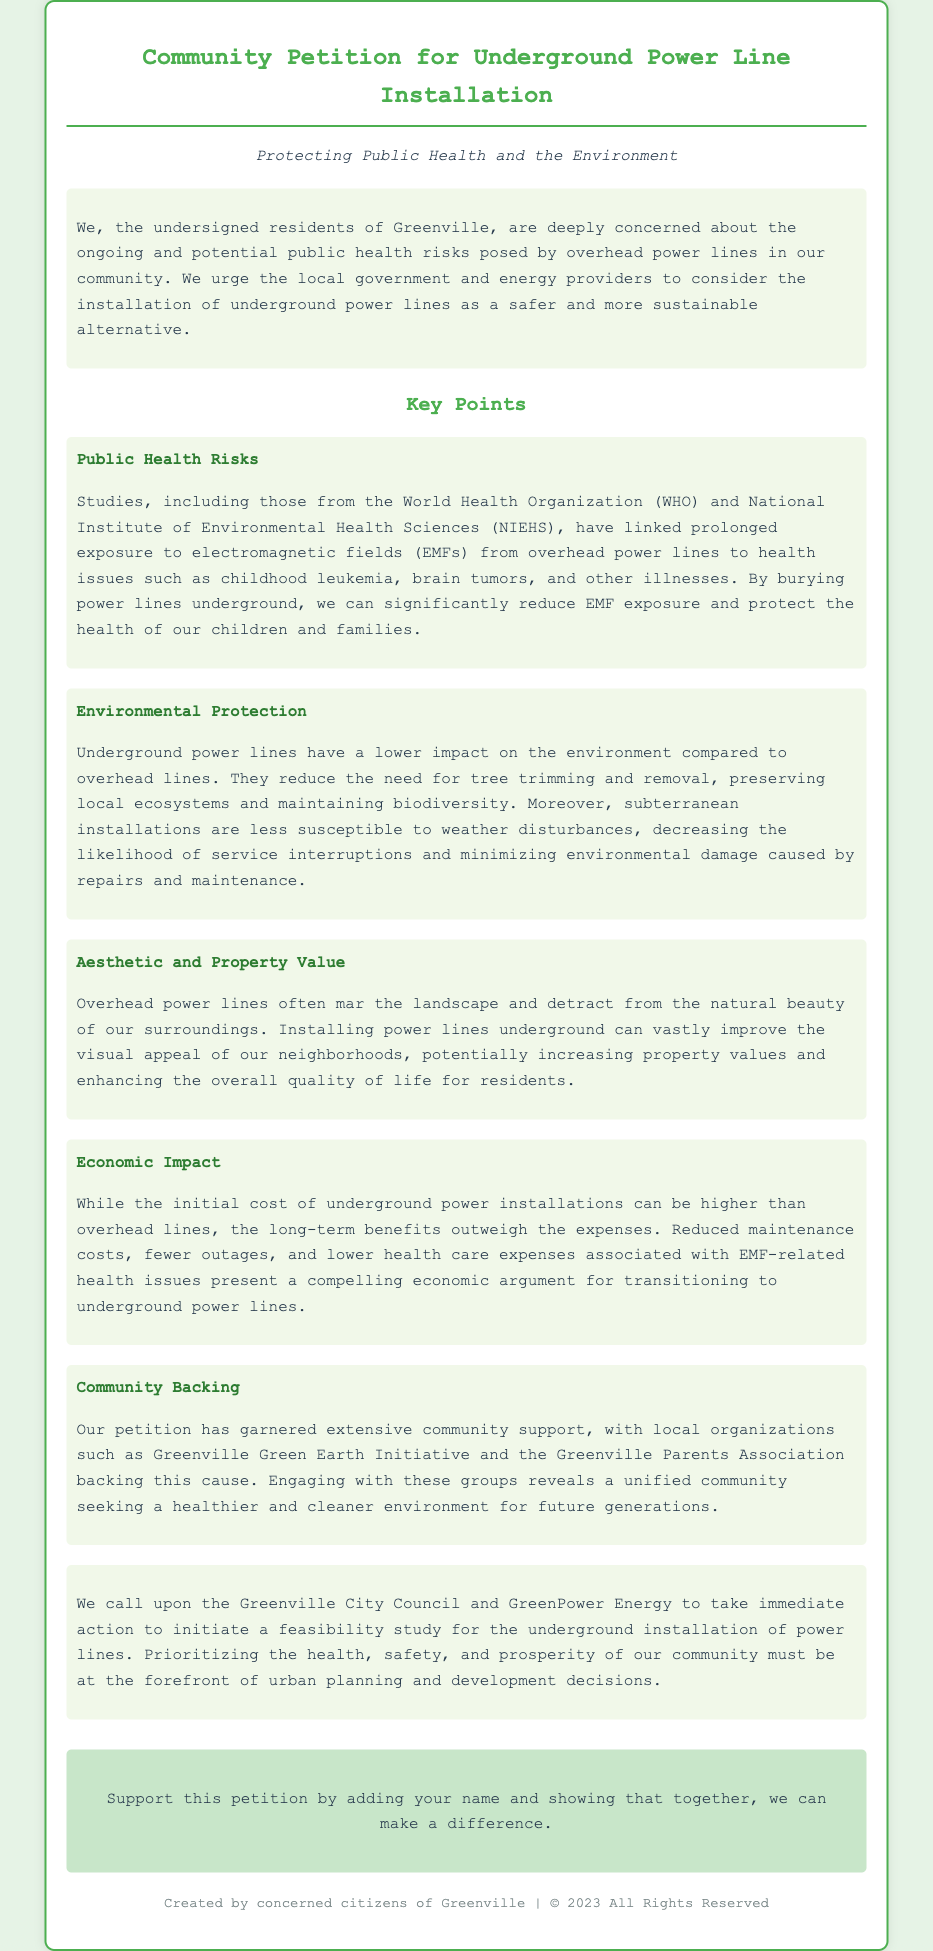What is the main concern of the residents of Greenville? The residents are concerned about the ongoing and potential public health risks posed by overhead power lines.
Answer: public health risks Which organizations are backing the petition? The document mentions local organizations supporting the petition. Specifically, it names the Greenville Green Earth Initiative and the Greenville Parents Association.
Answer: Greenville Green Earth Initiative, Greenville Parents Association What health issues are linked to overhead power lines according to the document? The document cites several health issues linked to overhead power lines, including childhood leukemia and brain tumors.
Answer: childhood leukemia, brain tumors What is one environmental benefit of underground power lines? The document states that underground power lines reduce the need for tree trimming and removal, which helps preserve local ecosystems.
Answer: preserve local ecosystems What economic argument is made for underground power lines? The document mentions that reduced maintenance costs and lower health care expenses associated with EMF-related health issues present a compelling economic argument.
Answer: reduced maintenance costs, lower health care expenses What is the call to action made by the petition? The petition calls upon the Greenville City Council and GreenPower Energy to initiate a feasibility study for the underground installation of power lines.
Answer: initiate a feasibility study How does the installation of underground power lines affect property values? The document indicates that installing power lines underground can improve the visual appeal of neighborhoods and potentially increase property values.
Answer: increase property values What type of study do the petitioners want the local government to initiate? The petitioners request a feasibility study regarding underground power line installation.
Answer: feasibility study 